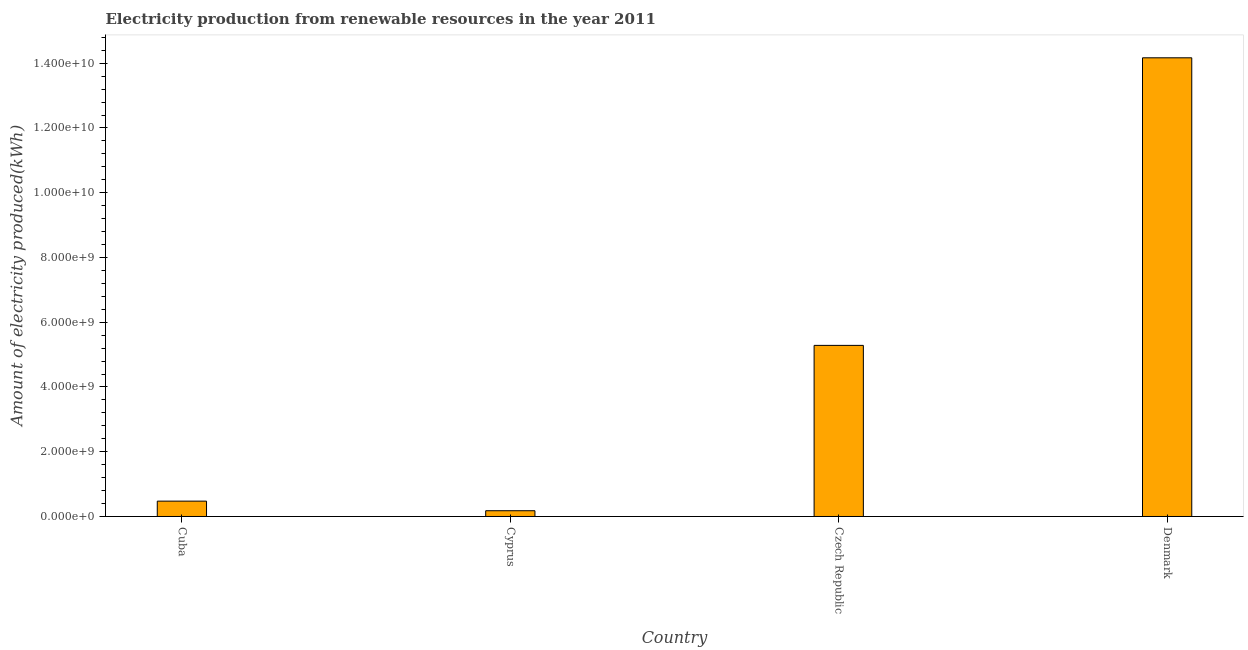Does the graph contain grids?
Offer a terse response. No. What is the title of the graph?
Give a very brief answer. Electricity production from renewable resources in the year 2011. What is the label or title of the Y-axis?
Provide a succinct answer. Amount of electricity produced(kWh). What is the amount of electricity produced in Cyprus?
Keep it short and to the point. 1.78e+08. Across all countries, what is the maximum amount of electricity produced?
Your answer should be very brief. 1.42e+1. Across all countries, what is the minimum amount of electricity produced?
Your response must be concise. 1.78e+08. In which country was the amount of electricity produced minimum?
Your response must be concise. Cyprus. What is the sum of the amount of electricity produced?
Your response must be concise. 2.01e+1. What is the difference between the amount of electricity produced in Cyprus and Czech Republic?
Your answer should be very brief. -5.11e+09. What is the average amount of electricity produced per country?
Keep it short and to the point. 5.03e+09. What is the median amount of electricity produced?
Keep it short and to the point. 2.88e+09. In how many countries, is the amount of electricity produced greater than 6000000000 kWh?
Provide a succinct answer. 1. What is the ratio of the amount of electricity produced in Cyprus to that in Denmark?
Your response must be concise. 0.01. Is the difference between the amount of electricity produced in Cyprus and Czech Republic greater than the difference between any two countries?
Your answer should be very brief. No. What is the difference between the highest and the second highest amount of electricity produced?
Keep it short and to the point. 8.88e+09. Is the sum of the amount of electricity produced in Cuba and Cyprus greater than the maximum amount of electricity produced across all countries?
Your answer should be compact. No. What is the difference between the highest and the lowest amount of electricity produced?
Ensure brevity in your answer.  1.40e+1. In how many countries, is the amount of electricity produced greater than the average amount of electricity produced taken over all countries?
Provide a succinct answer. 2. Are the values on the major ticks of Y-axis written in scientific E-notation?
Provide a succinct answer. Yes. What is the Amount of electricity produced(kWh) of Cuba?
Your answer should be compact. 4.74e+08. What is the Amount of electricity produced(kWh) of Cyprus?
Offer a terse response. 1.78e+08. What is the Amount of electricity produced(kWh) of Czech Republic?
Offer a very short reply. 5.28e+09. What is the Amount of electricity produced(kWh) of Denmark?
Provide a short and direct response. 1.42e+1. What is the difference between the Amount of electricity produced(kWh) in Cuba and Cyprus?
Make the answer very short. 2.96e+08. What is the difference between the Amount of electricity produced(kWh) in Cuba and Czech Republic?
Provide a succinct answer. -4.81e+09. What is the difference between the Amount of electricity produced(kWh) in Cuba and Denmark?
Give a very brief answer. -1.37e+1. What is the difference between the Amount of electricity produced(kWh) in Cyprus and Czech Republic?
Provide a short and direct response. -5.11e+09. What is the difference between the Amount of electricity produced(kWh) in Cyprus and Denmark?
Your answer should be compact. -1.40e+1. What is the difference between the Amount of electricity produced(kWh) in Czech Republic and Denmark?
Your answer should be very brief. -8.88e+09. What is the ratio of the Amount of electricity produced(kWh) in Cuba to that in Cyprus?
Your answer should be very brief. 2.66. What is the ratio of the Amount of electricity produced(kWh) in Cuba to that in Czech Republic?
Provide a short and direct response. 0.09. What is the ratio of the Amount of electricity produced(kWh) in Cuba to that in Denmark?
Offer a terse response. 0.03. What is the ratio of the Amount of electricity produced(kWh) in Cyprus to that in Czech Republic?
Offer a very short reply. 0.03. What is the ratio of the Amount of electricity produced(kWh) in Cyprus to that in Denmark?
Offer a terse response. 0.01. What is the ratio of the Amount of electricity produced(kWh) in Czech Republic to that in Denmark?
Give a very brief answer. 0.37. 